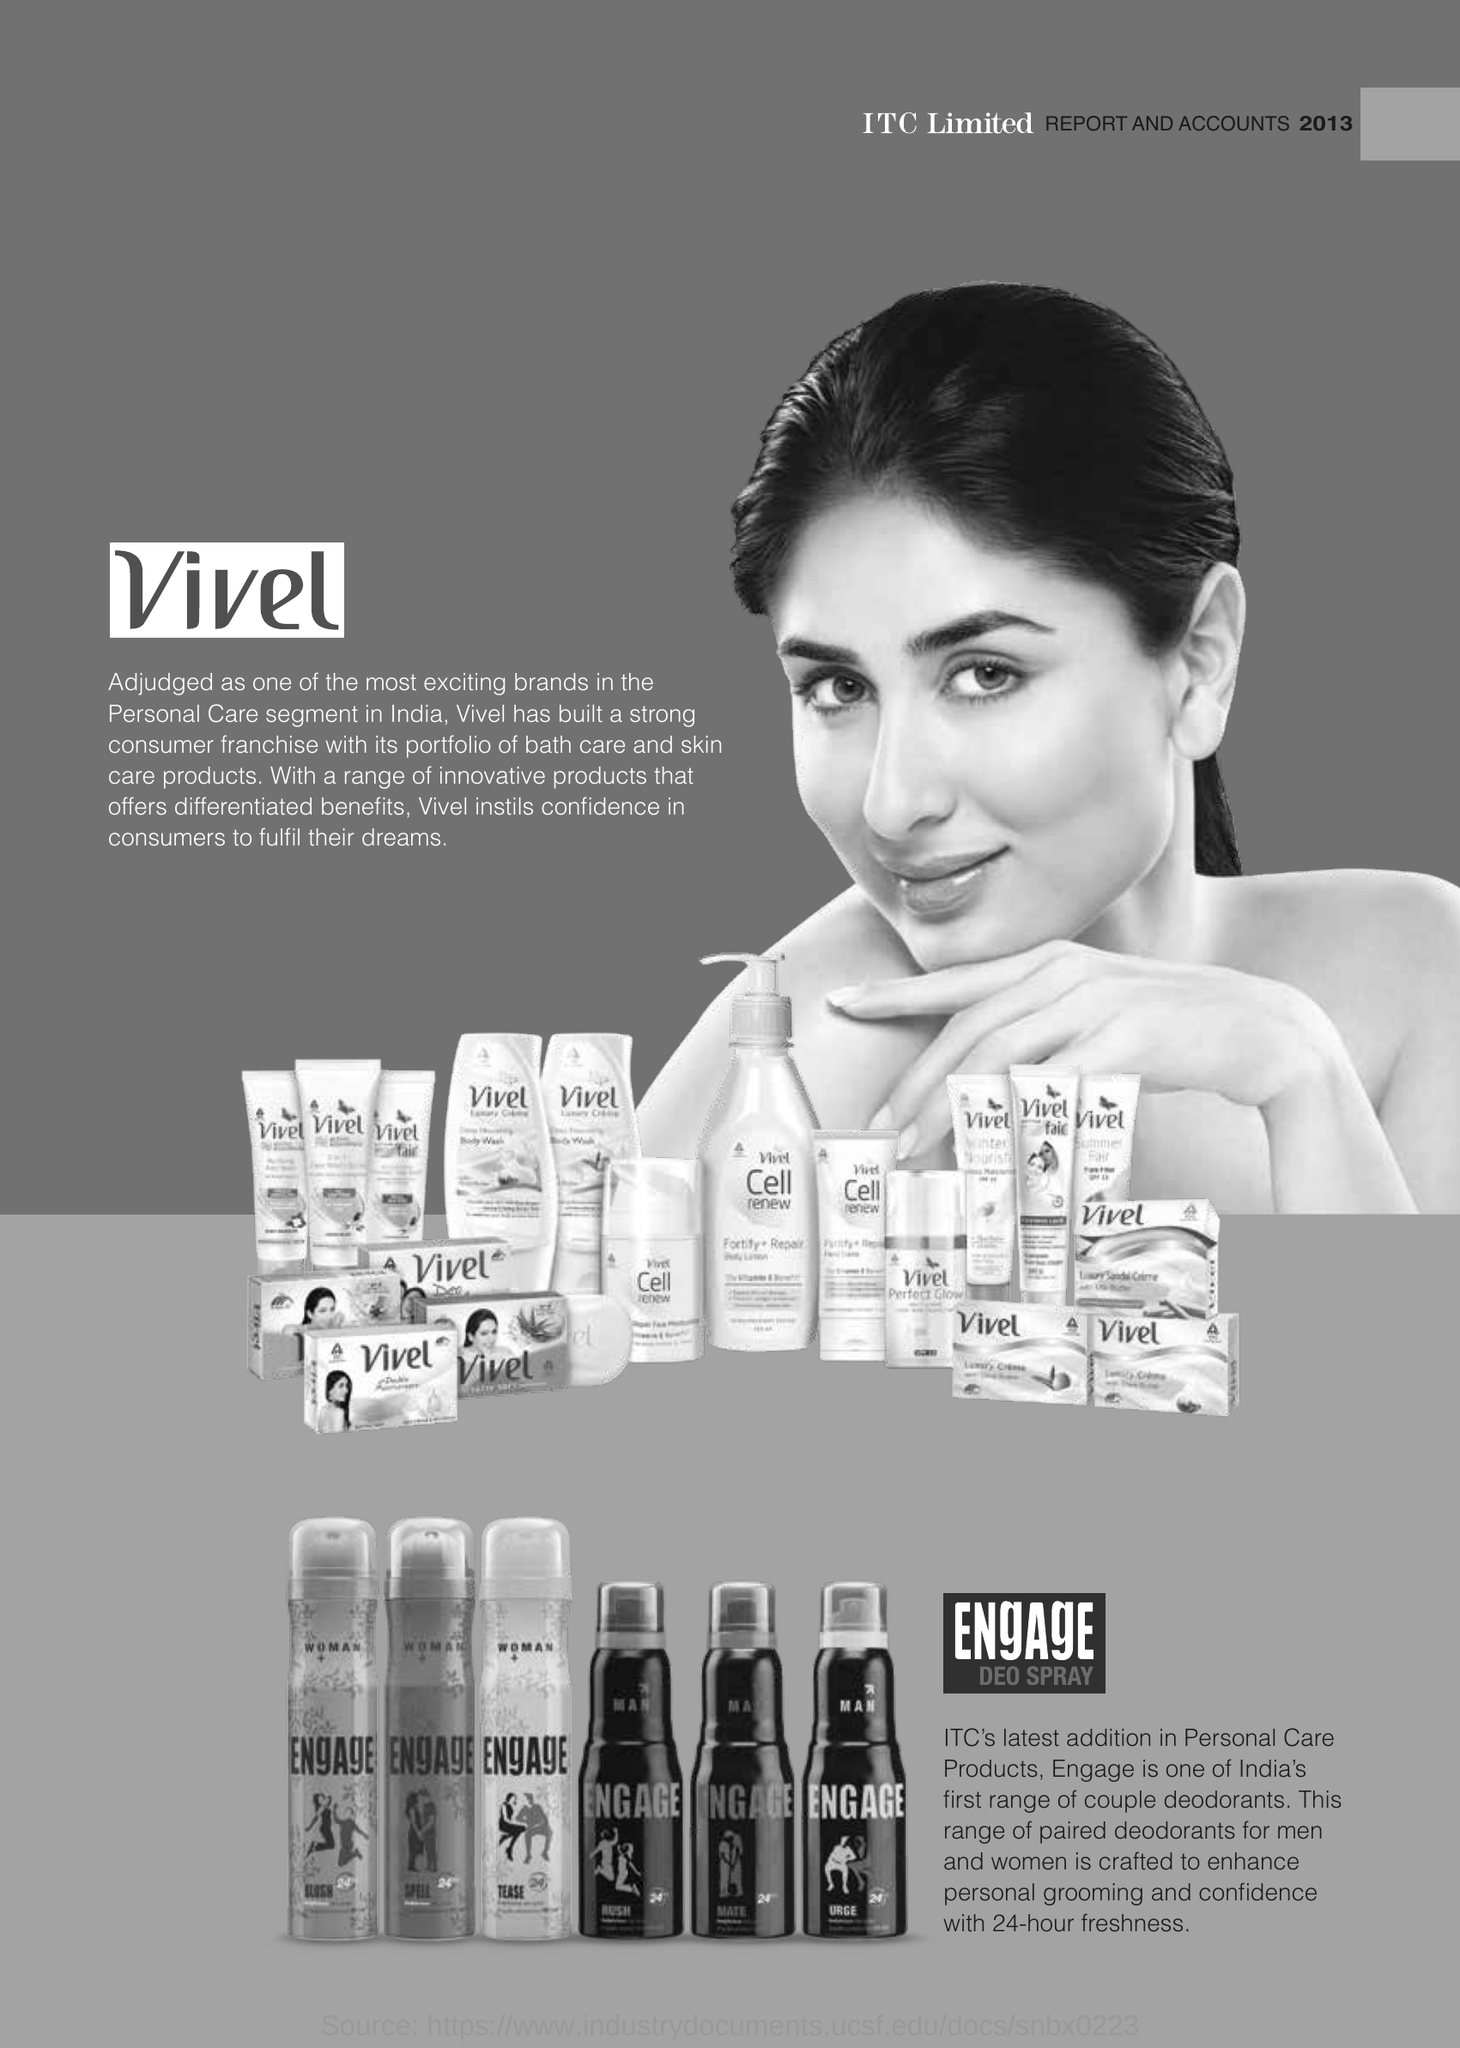Give some essential details in this illustration. India's first range of couple deodorants, Engage, is now available. Vivel is considered one of the most exciting bands in the personal care segment in India, according to many. The number of hours of freshness provided by the 'Engage' product is 24 hours. 